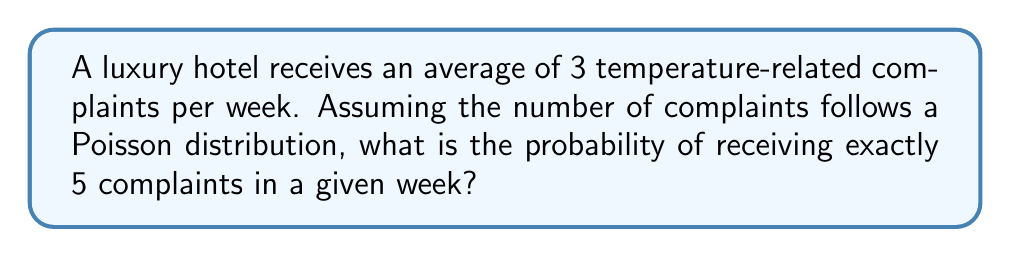Can you answer this question? To solve this problem, we'll use the Poisson distribution formula:

$$P(X = k) = \frac{e^{-\lambda} \lambda^k}{k!}$$

Where:
$\lambda$ = average number of events (complaints) per time period
$k$ = number of events we're calculating the probability for
$e$ = Euler's number (approximately 2.71828)

Given:
$\lambda = 3$ (average complaints per week)
$k = 5$ (number of complaints we're interested in)

Step 1: Plug the values into the formula
$$P(X = 5) = \frac{e^{-3} 3^5}{5!}$$

Step 2: Calculate $3^5$
$$3^5 = 243$$

Step 3: Calculate $5!$
$$5! = 5 \times 4 \times 3 \times 2 \times 1 = 120$$

Step 4: Evaluate $e^{-3}$
$$e^{-3} \approx 0.0497871$$

Step 5: Put it all together and calculate
$$P(X = 5) = \frac{0.0497871 \times 243}{120} \approx 0.1008$$

Therefore, the probability of receiving exactly 5 temperature-related complaints in a week is approximately 0.1008 or 10.08%.
Answer: $0.1008$ or $10.08\%$ 